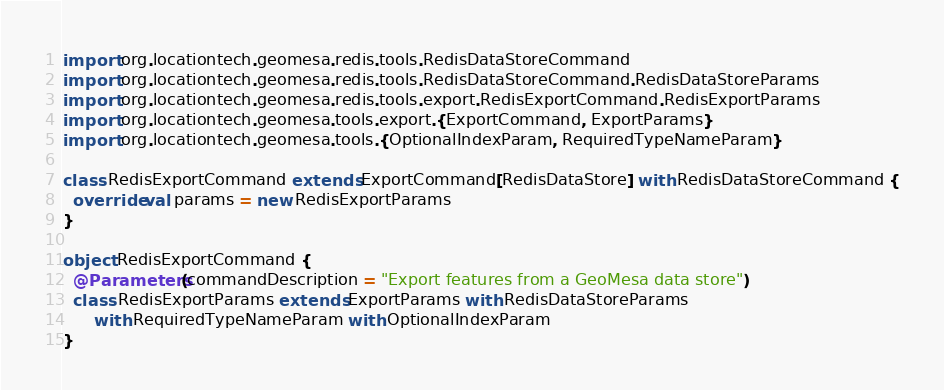Convert code to text. <code><loc_0><loc_0><loc_500><loc_500><_Scala_>import org.locationtech.geomesa.redis.tools.RedisDataStoreCommand
import org.locationtech.geomesa.redis.tools.RedisDataStoreCommand.RedisDataStoreParams
import org.locationtech.geomesa.redis.tools.export.RedisExportCommand.RedisExportParams
import org.locationtech.geomesa.tools.export.{ExportCommand, ExportParams}
import org.locationtech.geomesa.tools.{OptionalIndexParam, RequiredTypeNameParam}

class RedisExportCommand extends ExportCommand[RedisDataStore] with RedisDataStoreCommand {
  override val params = new RedisExportParams
}

object RedisExportCommand {
  @Parameters(commandDescription = "Export features from a GeoMesa data store")
  class RedisExportParams extends ExportParams with RedisDataStoreParams
      with RequiredTypeNameParam with OptionalIndexParam
}
</code> 